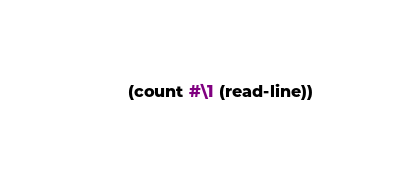<code> <loc_0><loc_0><loc_500><loc_500><_Lisp_>(count #\1 (read-line))
</code> 